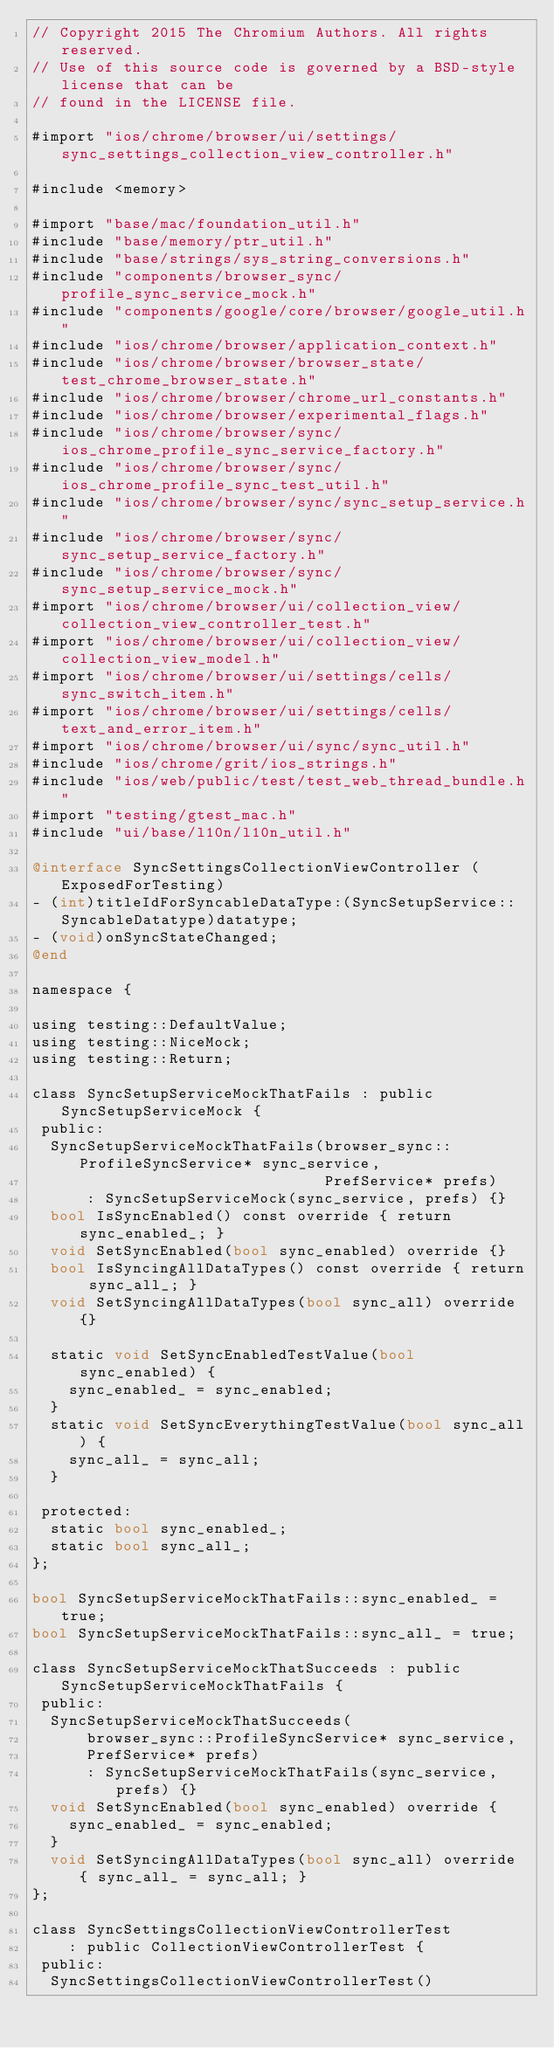Convert code to text. <code><loc_0><loc_0><loc_500><loc_500><_ObjectiveC_>// Copyright 2015 The Chromium Authors. All rights reserved.
// Use of this source code is governed by a BSD-style license that can be
// found in the LICENSE file.

#import "ios/chrome/browser/ui/settings/sync_settings_collection_view_controller.h"

#include <memory>

#import "base/mac/foundation_util.h"
#include "base/memory/ptr_util.h"
#include "base/strings/sys_string_conversions.h"
#include "components/browser_sync/profile_sync_service_mock.h"
#include "components/google/core/browser/google_util.h"
#include "ios/chrome/browser/application_context.h"
#include "ios/chrome/browser/browser_state/test_chrome_browser_state.h"
#include "ios/chrome/browser/chrome_url_constants.h"
#include "ios/chrome/browser/experimental_flags.h"
#include "ios/chrome/browser/sync/ios_chrome_profile_sync_service_factory.h"
#include "ios/chrome/browser/sync/ios_chrome_profile_sync_test_util.h"
#include "ios/chrome/browser/sync/sync_setup_service.h"
#include "ios/chrome/browser/sync/sync_setup_service_factory.h"
#include "ios/chrome/browser/sync/sync_setup_service_mock.h"
#import "ios/chrome/browser/ui/collection_view/collection_view_controller_test.h"
#import "ios/chrome/browser/ui/collection_view/collection_view_model.h"
#import "ios/chrome/browser/ui/settings/cells/sync_switch_item.h"
#import "ios/chrome/browser/ui/settings/cells/text_and_error_item.h"
#import "ios/chrome/browser/ui/sync/sync_util.h"
#include "ios/chrome/grit/ios_strings.h"
#include "ios/web/public/test/test_web_thread_bundle.h"
#import "testing/gtest_mac.h"
#include "ui/base/l10n/l10n_util.h"

@interface SyncSettingsCollectionViewController (ExposedForTesting)
- (int)titleIdForSyncableDataType:(SyncSetupService::SyncableDatatype)datatype;
- (void)onSyncStateChanged;
@end

namespace {

using testing::DefaultValue;
using testing::NiceMock;
using testing::Return;

class SyncSetupServiceMockThatFails : public SyncSetupServiceMock {
 public:
  SyncSetupServiceMockThatFails(browser_sync::ProfileSyncService* sync_service,
                                PrefService* prefs)
      : SyncSetupServiceMock(sync_service, prefs) {}
  bool IsSyncEnabled() const override { return sync_enabled_; }
  void SetSyncEnabled(bool sync_enabled) override {}
  bool IsSyncingAllDataTypes() const override { return sync_all_; }
  void SetSyncingAllDataTypes(bool sync_all) override {}

  static void SetSyncEnabledTestValue(bool sync_enabled) {
    sync_enabled_ = sync_enabled;
  }
  static void SetSyncEverythingTestValue(bool sync_all) {
    sync_all_ = sync_all;
  }

 protected:
  static bool sync_enabled_;
  static bool sync_all_;
};

bool SyncSetupServiceMockThatFails::sync_enabled_ = true;
bool SyncSetupServiceMockThatFails::sync_all_ = true;

class SyncSetupServiceMockThatSucceeds : public SyncSetupServiceMockThatFails {
 public:
  SyncSetupServiceMockThatSucceeds(
      browser_sync::ProfileSyncService* sync_service,
      PrefService* prefs)
      : SyncSetupServiceMockThatFails(sync_service, prefs) {}
  void SetSyncEnabled(bool sync_enabled) override {
    sync_enabled_ = sync_enabled;
  }
  void SetSyncingAllDataTypes(bool sync_all) override { sync_all_ = sync_all; }
};

class SyncSettingsCollectionViewControllerTest
    : public CollectionViewControllerTest {
 public:
  SyncSettingsCollectionViewControllerTest()</code> 